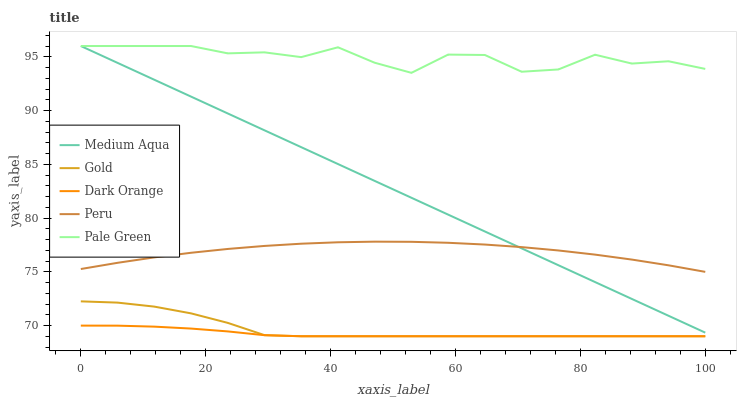Does Dark Orange have the minimum area under the curve?
Answer yes or no. Yes. Does Pale Green have the maximum area under the curve?
Answer yes or no. Yes. Does Medium Aqua have the minimum area under the curve?
Answer yes or no. No. Does Medium Aqua have the maximum area under the curve?
Answer yes or no. No. Is Medium Aqua the smoothest?
Answer yes or no. Yes. Is Pale Green the roughest?
Answer yes or no. Yes. Is Pale Green the smoothest?
Answer yes or no. No. Is Medium Aqua the roughest?
Answer yes or no. No. Does Medium Aqua have the lowest value?
Answer yes or no. No. Does Medium Aqua have the highest value?
Answer yes or no. Yes. Does Peru have the highest value?
Answer yes or no. No. Is Gold less than Medium Aqua?
Answer yes or no. Yes. Is Peru greater than Gold?
Answer yes or no. Yes. Does Gold intersect Dark Orange?
Answer yes or no. Yes. Is Gold less than Dark Orange?
Answer yes or no. No. Is Gold greater than Dark Orange?
Answer yes or no. No. Does Gold intersect Medium Aqua?
Answer yes or no. No. 